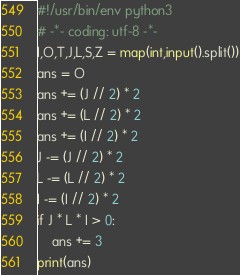Convert code to text. <code><loc_0><loc_0><loc_500><loc_500><_Python_>#!/usr/bin/env python3
# -*- coding: utf-8 -*-
I,O,T,J,L,S,Z = map(int,input().split())
ans = O
ans += (J // 2) * 2
ans += (L // 2) * 2
ans += (I // 2) * 2
J -= (J // 2) * 2
L -= (L // 2) * 2
I -= (I // 2) * 2
if J * L * I > 0:
    ans += 3
print(ans)


</code> 